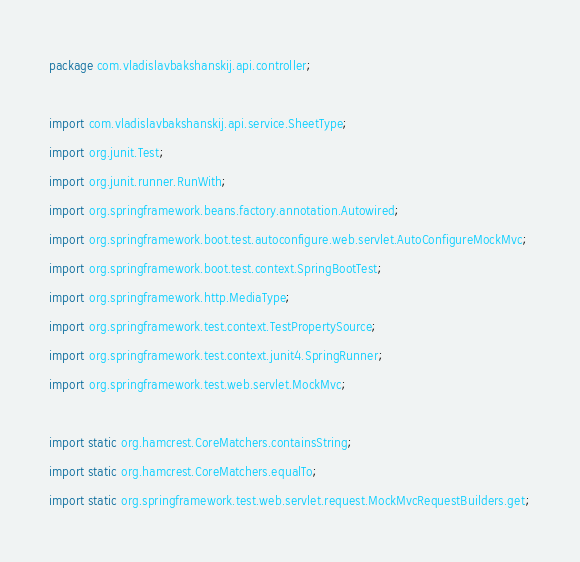<code> <loc_0><loc_0><loc_500><loc_500><_Java_>package com.vladislavbakshanskij.api.controller;

import com.vladislavbakshanskij.api.service.SheetType;
import org.junit.Test;
import org.junit.runner.RunWith;
import org.springframework.beans.factory.annotation.Autowired;
import org.springframework.boot.test.autoconfigure.web.servlet.AutoConfigureMockMvc;
import org.springframework.boot.test.context.SpringBootTest;
import org.springframework.http.MediaType;
import org.springframework.test.context.TestPropertySource;
import org.springframework.test.context.junit4.SpringRunner;
import org.springframework.test.web.servlet.MockMvc;

import static org.hamcrest.CoreMatchers.containsString;
import static org.hamcrest.CoreMatchers.equalTo;
import static org.springframework.test.web.servlet.request.MockMvcRequestBuilders.get;</code> 